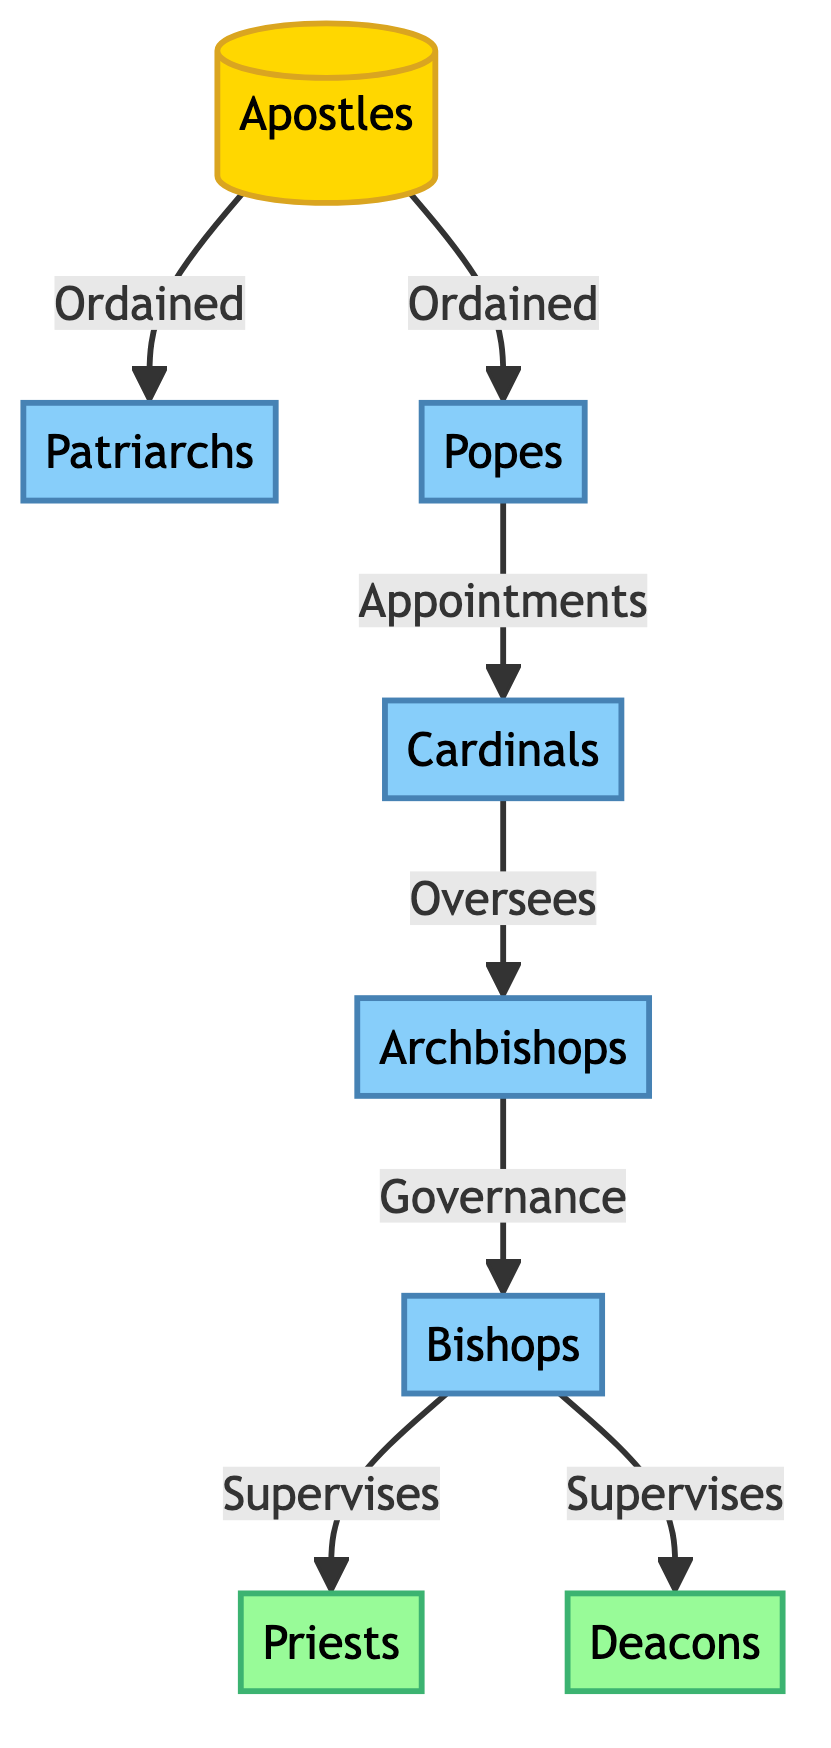What is the origin of the Church hierarchy? The diagram shows that the Apostles are the origin of the Church hierarchy, as they are the first element in the flow leading to all subsequent hierarchies. They are directly connected to both Patriarchs and Popes, indicating their foundational role.
Answer: Apostles How many levels of hierarchy are depicted in the diagram? Counting from the Apostles down to the lowest local leadership, there are six levels: Apostles, Patriarchs, Popes, Cardinals, Archbishops, and Bishops. Each of these represents a distinct layer of leadership in the Church hierarchy.
Answer: Six Which node directly oversees Archbishops? The diagram indicates that Cardinals directly oversee Archbishops, as there is a directed connection from Cardinals to Archbishops labeled "Oversees." This shows the hierarchical relationship between these two positions.
Answer: Cardinals What is the relationship between Popes and Cardinals? The connection between Popes and Cardinals is labeled "Appointments," indicating that the Pope is responsible for appointing Cardinals within the Church hierarchy. This relationship defines how Cardinals are selected.
Answer: Appointments Who supervises both Priests and Deacons? According to the diagram, Bishops supervise both Priests and Deacons, as reflected in the two separate connections labeled "Supervises" from Bishops to both local leadership roles. This emphasizes the Bishops' governing role over these clergy.
Answer: Bishops How are the historical roles of the Apostles connected to the Popes? The connection shows that Apostles are the origin, and they are both ordained to the role of Popes, establishing a direct link from the foundational figures to the leaders of the Catholic Church today. This demonstrates succession from the Apostles to the current Pope.
Answer: Ordained What color represents the local leadership roles in the diagram? The local leadership roles, represented by Priests and Deacons, are colored in a light green shade. This distinguishes them from the other hierarchical roles, aiding in quick identification of local church leadership in the diagram.
Answer: Light green Which hierarchy directly connects to the local leadership? The Bishops are the hierarchy that directly connects to local leadership, as indicated by the arrows leading from the Bishops to both Priests and Deacons, marking them as supervisory figures over local clergy.
Answer: Bishops 